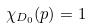<formula> <loc_0><loc_0><loc_500><loc_500>\chi _ { D _ { 0 } } ( p ) = 1</formula> 